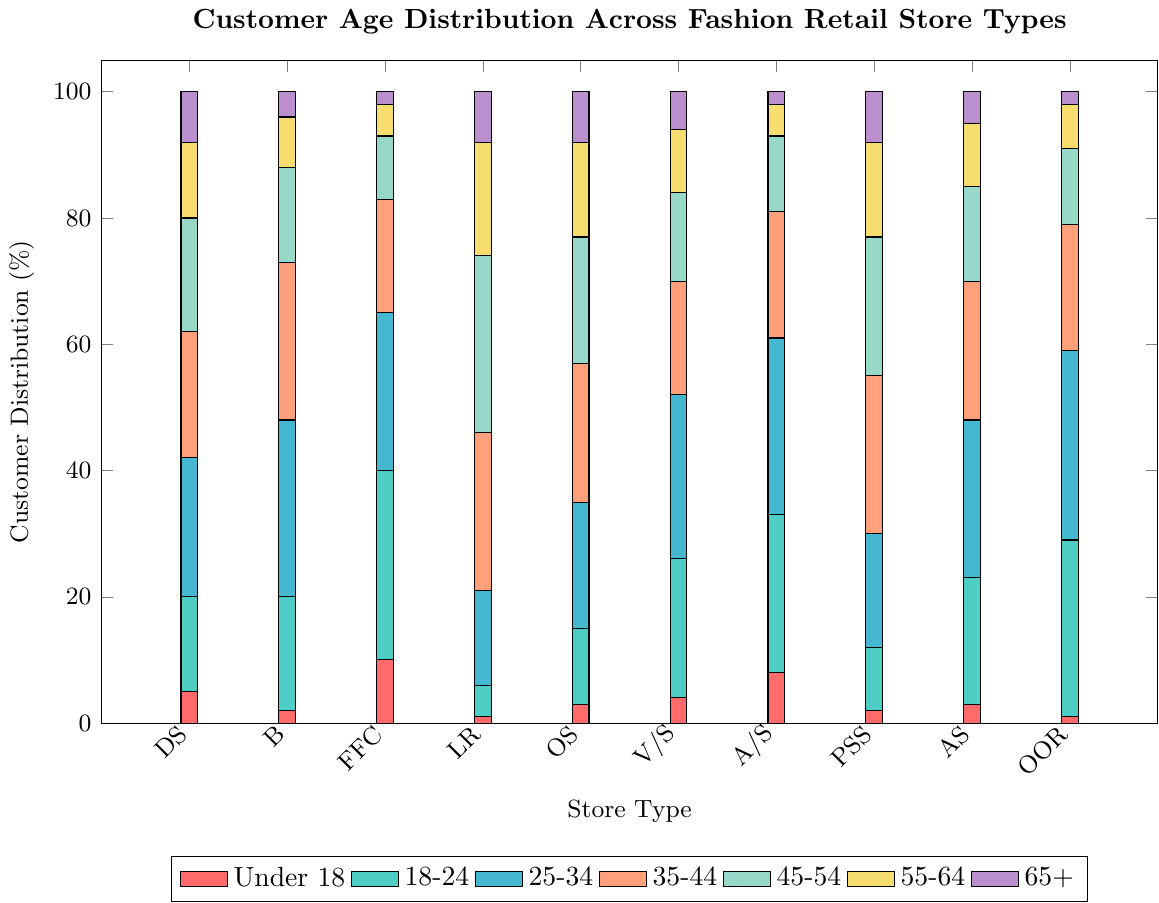Which store type has the highest percentage of customers aged 18-24? The highest bar in the '18-24' category, which is colored green, can be observed for Fast Fashion Chains among all store types.
Answer: Fast Fashion Chains What's the total percentage of customers aged 55-64 across all store types? Add the heights of the yellow bars (representing 55-64) across all store types: 12 (DS) + 8 (B) + 5 (FFC) + 18 (LR) + 15 (OS) + 10 (V/S) + 5 (A/S) + 15 (PSS) + 10 (AS) + 7 (OOR) = 105.
Answer: 105 Which age group has the smallest percentage of customers in Online-Only Retailers? The smallest bar for Online-Only Retailers among the various colored segments corresponds to the 'Under 18' category, which is colored red.
Answer: Under 18 Compare the percentage of customers aged 35-44 between Luxury Retailers and Plus-Size Specialty stores. Which one is higher? The blue bars for the '35-44' category are analyzed. Luxury Retailers have a 25% and Plus-Size Specialty stores have a 25%, so they are equal.
Answer: Equal Which age group forms the majority of customers in Boutiques? The highest bar segment for Boutiques can be observed in the '25-34' category, colored sky blue.
Answer: 25-34 What is the average percentage of customers aged 45-54 across Department Stores, Outlet Stores, and Athletic/Sportswear stores? The percentages for the '45-54' category are 18 (DS) + 20 (OS) + 12 (A/S). Calculate the average: (18 + 20 + 12) / 3 = 50 / 3 ≈ 16.67.
Answer: ~16.67 In which store type do customers aged under 18 form a higher percentage than those aged 65+? Compare the red ('Under 18') bars to the purple ('65+') bars for each store type. Fast Fashion Chains and Athletic/Sportswear have higher 'Under 18' percentages (10 and 8) compared to '65+' percentages (2 and 2).
Answer: Fast Fashion Chains, Athletic/Sportswear Comparing Department Stores and Vintage/Secondhand stores, which has a higher total percentage of customers aged under 35? Sum the percentages for 'Under 18', '18-24', and '25-34' bars in both stores: 
  - Department Stores: 5 (U18) + 15 (18-24) + 22 (25-34) = 42
  - Vintage/Secondhand: 4 (U18) + 22 (18-24) + 26 (25-34) = 52
Vintage/Secondhand has a higher total.
Answer: Vintage/Secondhand 